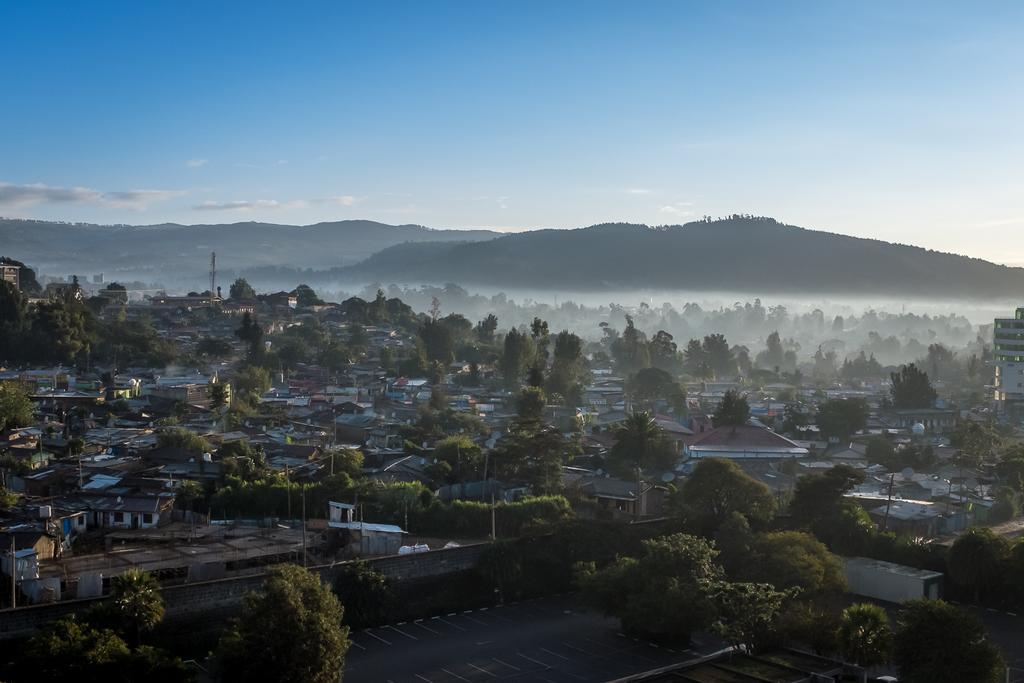In one or two sentences, can you explain what this image depicts? In the picture there are many trees, there are buildings, there are many poles, there are hills, there is a clear sky. 